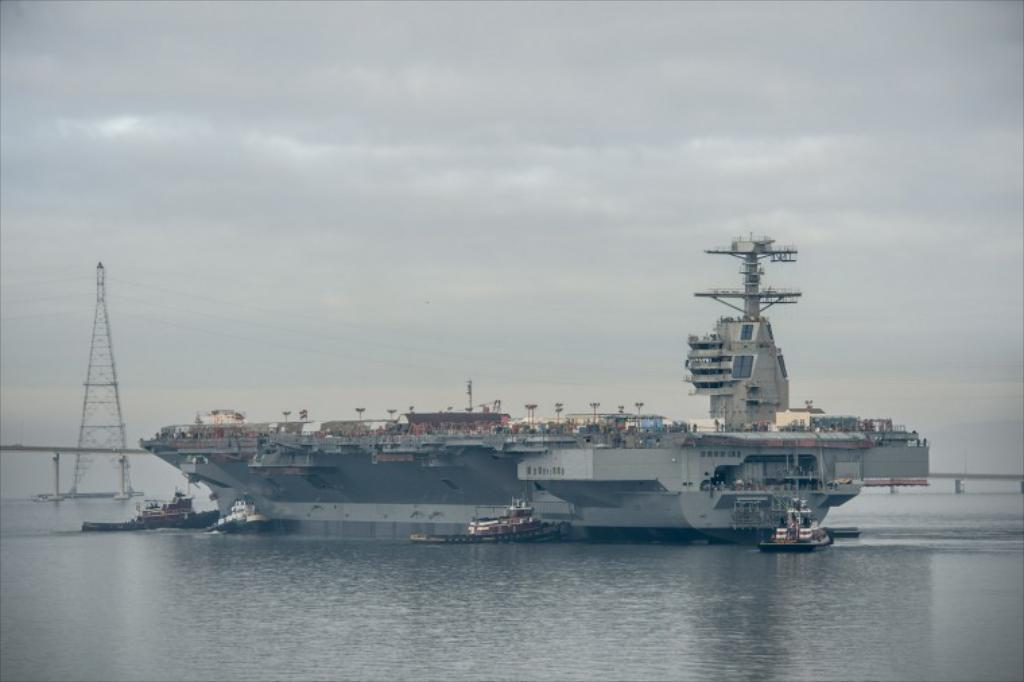What type of watercraft can be seen in the image? There is a ship and a boat in the image. Are the ship and boat in contact with the water? No, both the ship and boat are above the water in the image. What other structures can be seen in the image? There is a tower in the image. What else is present in the image besides the watercraft and tower? There are wires and the sky is visible in the background of the image. What can be observed in the sky? Clouds are present in the sky. How many loaves of bread can be seen on the ship in the image? There is no bread visible on the ship in the image. Are there any babies present on the boat in the image? There is no indication of babies or any people on the boat in the image. 